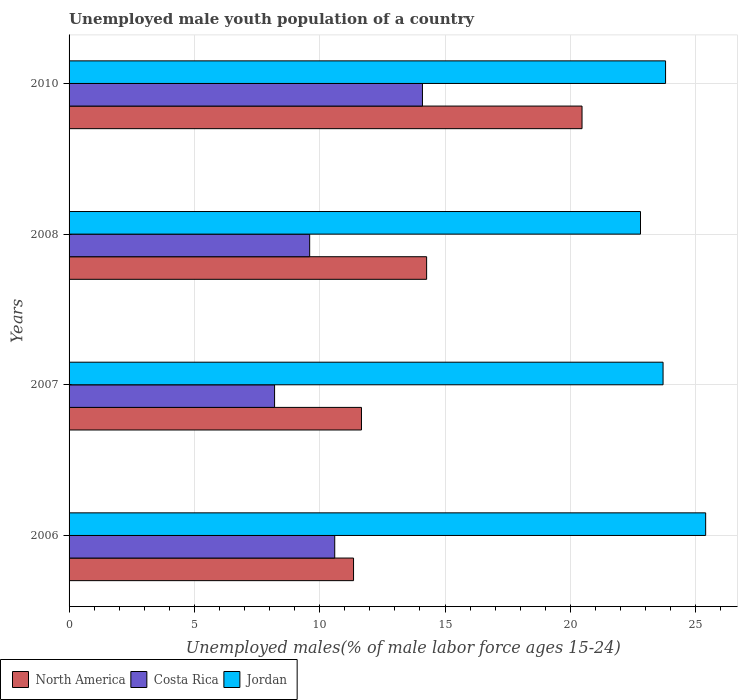How many different coloured bars are there?
Your answer should be very brief. 3. How many bars are there on the 3rd tick from the top?
Offer a very short reply. 3. What is the percentage of unemployed male youth population in North America in 2008?
Your answer should be compact. 14.27. Across all years, what is the maximum percentage of unemployed male youth population in North America?
Keep it short and to the point. 20.47. Across all years, what is the minimum percentage of unemployed male youth population in North America?
Provide a succinct answer. 11.35. In which year was the percentage of unemployed male youth population in Costa Rica maximum?
Provide a short and direct response. 2010. In which year was the percentage of unemployed male youth population in Jordan minimum?
Your answer should be very brief. 2008. What is the total percentage of unemployed male youth population in Jordan in the graph?
Ensure brevity in your answer.  95.7. What is the difference between the percentage of unemployed male youth population in Jordan in 2007 and that in 2008?
Make the answer very short. 0.9. What is the difference between the percentage of unemployed male youth population in Costa Rica in 2010 and the percentage of unemployed male youth population in Jordan in 2007?
Make the answer very short. -9.6. What is the average percentage of unemployed male youth population in Costa Rica per year?
Offer a terse response. 10.63. In the year 2007, what is the difference between the percentage of unemployed male youth population in Costa Rica and percentage of unemployed male youth population in North America?
Your answer should be very brief. -3.47. What is the ratio of the percentage of unemployed male youth population in Jordan in 2008 to that in 2010?
Keep it short and to the point. 0.96. Is the percentage of unemployed male youth population in Jordan in 2006 less than that in 2008?
Your answer should be very brief. No. Is the difference between the percentage of unemployed male youth population in Costa Rica in 2006 and 2010 greater than the difference between the percentage of unemployed male youth population in North America in 2006 and 2010?
Give a very brief answer. Yes. What is the difference between the highest and the second highest percentage of unemployed male youth population in Jordan?
Provide a short and direct response. 1.6. What is the difference between the highest and the lowest percentage of unemployed male youth population in Jordan?
Provide a short and direct response. 2.6. In how many years, is the percentage of unemployed male youth population in North America greater than the average percentage of unemployed male youth population in North America taken over all years?
Make the answer very short. 1. Is the sum of the percentage of unemployed male youth population in North America in 2007 and 2008 greater than the maximum percentage of unemployed male youth population in Costa Rica across all years?
Give a very brief answer. Yes. What does the 1st bar from the top in 2007 represents?
Your answer should be very brief. Jordan. What does the 3rd bar from the bottom in 2006 represents?
Keep it short and to the point. Jordan. Is it the case that in every year, the sum of the percentage of unemployed male youth population in Costa Rica and percentage of unemployed male youth population in North America is greater than the percentage of unemployed male youth population in Jordan?
Give a very brief answer. No. How many bars are there?
Your answer should be very brief. 12. Are all the bars in the graph horizontal?
Your response must be concise. Yes. Are the values on the major ticks of X-axis written in scientific E-notation?
Ensure brevity in your answer.  No. Does the graph contain any zero values?
Offer a very short reply. No. Where does the legend appear in the graph?
Provide a succinct answer. Bottom left. How many legend labels are there?
Provide a short and direct response. 3. What is the title of the graph?
Your answer should be very brief. Unemployed male youth population of a country. What is the label or title of the X-axis?
Make the answer very short. Unemployed males(% of male labor force ages 15-24). What is the Unemployed males(% of male labor force ages 15-24) in North America in 2006?
Give a very brief answer. 11.35. What is the Unemployed males(% of male labor force ages 15-24) of Costa Rica in 2006?
Make the answer very short. 10.6. What is the Unemployed males(% of male labor force ages 15-24) of Jordan in 2006?
Offer a very short reply. 25.4. What is the Unemployed males(% of male labor force ages 15-24) of North America in 2007?
Keep it short and to the point. 11.67. What is the Unemployed males(% of male labor force ages 15-24) of Costa Rica in 2007?
Your answer should be very brief. 8.2. What is the Unemployed males(% of male labor force ages 15-24) in Jordan in 2007?
Make the answer very short. 23.7. What is the Unemployed males(% of male labor force ages 15-24) of North America in 2008?
Your response must be concise. 14.27. What is the Unemployed males(% of male labor force ages 15-24) in Costa Rica in 2008?
Offer a terse response. 9.6. What is the Unemployed males(% of male labor force ages 15-24) of Jordan in 2008?
Ensure brevity in your answer.  22.8. What is the Unemployed males(% of male labor force ages 15-24) in North America in 2010?
Your answer should be compact. 20.47. What is the Unemployed males(% of male labor force ages 15-24) of Costa Rica in 2010?
Your answer should be very brief. 14.1. What is the Unemployed males(% of male labor force ages 15-24) of Jordan in 2010?
Keep it short and to the point. 23.8. Across all years, what is the maximum Unemployed males(% of male labor force ages 15-24) in North America?
Offer a very short reply. 20.47. Across all years, what is the maximum Unemployed males(% of male labor force ages 15-24) in Costa Rica?
Give a very brief answer. 14.1. Across all years, what is the maximum Unemployed males(% of male labor force ages 15-24) of Jordan?
Keep it short and to the point. 25.4. Across all years, what is the minimum Unemployed males(% of male labor force ages 15-24) of North America?
Offer a very short reply. 11.35. Across all years, what is the minimum Unemployed males(% of male labor force ages 15-24) of Costa Rica?
Keep it short and to the point. 8.2. Across all years, what is the minimum Unemployed males(% of male labor force ages 15-24) in Jordan?
Ensure brevity in your answer.  22.8. What is the total Unemployed males(% of male labor force ages 15-24) of North America in the graph?
Your answer should be very brief. 57.75. What is the total Unemployed males(% of male labor force ages 15-24) of Costa Rica in the graph?
Your answer should be compact. 42.5. What is the total Unemployed males(% of male labor force ages 15-24) in Jordan in the graph?
Offer a terse response. 95.7. What is the difference between the Unemployed males(% of male labor force ages 15-24) of North America in 2006 and that in 2007?
Give a very brief answer. -0.32. What is the difference between the Unemployed males(% of male labor force ages 15-24) in Costa Rica in 2006 and that in 2007?
Ensure brevity in your answer.  2.4. What is the difference between the Unemployed males(% of male labor force ages 15-24) of Jordan in 2006 and that in 2007?
Your answer should be very brief. 1.7. What is the difference between the Unemployed males(% of male labor force ages 15-24) in North America in 2006 and that in 2008?
Provide a short and direct response. -2.92. What is the difference between the Unemployed males(% of male labor force ages 15-24) of North America in 2006 and that in 2010?
Your response must be concise. -9.12. What is the difference between the Unemployed males(% of male labor force ages 15-24) of Costa Rica in 2006 and that in 2010?
Your response must be concise. -3.5. What is the difference between the Unemployed males(% of male labor force ages 15-24) of Jordan in 2006 and that in 2010?
Your answer should be compact. 1.6. What is the difference between the Unemployed males(% of male labor force ages 15-24) of North America in 2007 and that in 2008?
Keep it short and to the point. -2.6. What is the difference between the Unemployed males(% of male labor force ages 15-24) in Jordan in 2007 and that in 2008?
Provide a succinct answer. 0.9. What is the difference between the Unemployed males(% of male labor force ages 15-24) of North America in 2007 and that in 2010?
Offer a terse response. -8.8. What is the difference between the Unemployed males(% of male labor force ages 15-24) of North America in 2008 and that in 2010?
Make the answer very short. -6.2. What is the difference between the Unemployed males(% of male labor force ages 15-24) in North America in 2006 and the Unemployed males(% of male labor force ages 15-24) in Costa Rica in 2007?
Your answer should be compact. 3.15. What is the difference between the Unemployed males(% of male labor force ages 15-24) of North America in 2006 and the Unemployed males(% of male labor force ages 15-24) of Jordan in 2007?
Provide a short and direct response. -12.35. What is the difference between the Unemployed males(% of male labor force ages 15-24) in North America in 2006 and the Unemployed males(% of male labor force ages 15-24) in Costa Rica in 2008?
Provide a short and direct response. 1.75. What is the difference between the Unemployed males(% of male labor force ages 15-24) of North America in 2006 and the Unemployed males(% of male labor force ages 15-24) of Jordan in 2008?
Ensure brevity in your answer.  -11.45. What is the difference between the Unemployed males(% of male labor force ages 15-24) in North America in 2006 and the Unemployed males(% of male labor force ages 15-24) in Costa Rica in 2010?
Offer a very short reply. -2.75. What is the difference between the Unemployed males(% of male labor force ages 15-24) in North America in 2006 and the Unemployed males(% of male labor force ages 15-24) in Jordan in 2010?
Your answer should be very brief. -12.45. What is the difference between the Unemployed males(% of male labor force ages 15-24) of Costa Rica in 2006 and the Unemployed males(% of male labor force ages 15-24) of Jordan in 2010?
Make the answer very short. -13.2. What is the difference between the Unemployed males(% of male labor force ages 15-24) in North America in 2007 and the Unemployed males(% of male labor force ages 15-24) in Costa Rica in 2008?
Keep it short and to the point. 2.07. What is the difference between the Unemployed males(% of male labor force ages 15-24) in North America in 2007 and the Unemployed males(% of male labor force ages 15-24) in Jordan in 2008?
Your answer should be compact. -11.13. What is the difference between the Unemployed males(% of male labor force ages 15-24) of Costa Rica in 2007 and the Unemployed males(% of male labor force ages 15-24) of Jordan in 2008?
Your response must be concise. -14.6. What is the difference between the Unemployed males(% of male labor force ages 15-24) in North America in 2007 and the Unemployed males(% of male labor force ages 15-24) in Costa Rica in 2010?
Your response must be concise. -2.43. What is the difference between the Unemployed males(% of male labor force ages 15-24) of North America in 2007 and the Unemployed males(% of male labor force ages 15-24) of Jordan in 2010?
Provide a succinct answer. -12.13. What is the difference between the Unemployed males(% of male labor force ages 15-24) of Costa Rica in 2007 and the Unemployed males(% of male labor force ages 15-24) of Jordan in 2010?
Make the answer very short. -15.6. What is the difference between the Unemployed males(% of male labor force ages 15-24) of North America in 2008 and the Unemployed males(% of male labor force ages 15-24) of Jordan in 2010?
Give a very brief answer. -9.53. What is the average Unemployed males(% of male labor force ages 15-24) in North America per year?
Provide a short and direct response. 14.44. What is the average Unemployed males(% of male labor force ages 15-24) in Costa Rica per year?
Provide a succinct answer. 10.62. What is the average Unemployed males(% of male labor force ages 15-24) in Jordan per year?
Give a very brief answer. 23.93. In the year 2006, what is the difference between the Unemployed males(% of male labor force ages 15-24) of North America and Unemployed males(% of male labor force ages 15-24) of Costa Rica?
Give a very brief answer. 0.75. In the year 2006, what is the difference between the Unemployed males(% of male labor force ages 15-24) in North America and Unemployed males(% of male labor force ages 15-24) in Jordan?
Provide a short and direct response. -14.05. In the year 2006, what is the difference between the Unemployed males(% of male labor force ages 15-24) in Costa Rica and Unemployed males(% of male labor force ages 15-24) in Jordan?
Provide a succinct answer. -14.8. In the year 2007, what is the difference between the Unemployed males(% of male labor force ages 15-24) in North America and Unemployed males(% of male labor force ages 15-24) in Costa Rica?
Ensure brevity in your answer.  3.47. In the year 2007, what is the difference between the Unemployed males(% of male labor force ages 15-24) of North America and Unemployed males(% of male labor force ages 15-24) of Jordan?
Your answer should be very brief. -12.03. In the year 2007, what is the difference between the Unemployed males(% of male labor force ages 15-24) in Costa Rica and Unemployed males(% of male labor force ages 15-24) in Jordan?
Give a very brief answer. -15.5. In the year 2008, what is the difference between the Unemployed males(% of male labor force ages 15-24) of North America and Unemployed males(% of male labor force ages 15-24) of Costa Rica?
Offer a very short reply. 4.67. In the year 2008, what is the difference between the Unemployed males(% of male labor force ages 15-24) of North America and Unemployed males(% of male labor force ages 15-24) of Jordan?
Offer a terse response. -8.53. In the year 2010, what is the difference between the Unemployed males(% of male labor force ages 15-24) of North America and Unemployed males(% of male labor force ages 15-24) of Costa Rica?
Give a very brief answer. 6.37. In the year 2010, what is the difference between the Unemployed males(% of male labor force ages 15-24) of North America and Unemployed males(% of male labor force ages 15-24) of Jordan?
Provide a short and direct response. -3.33. What is the ratio of the Unemployed males(% of male labor force ages 15-24) in North America in 2006 to that in 2007?
Offer a terse response. 0.97. What is the ratio of the Unemployed males(% of male labor force ages 15-24) of Costa Rica in 2006 to that in 2007?
Keep it short and to the point. 1.29. What is the ratio of the Unemployed males(% of male labor force ages 15-24) of Jordan in 2006 to that in 2007?
Ensure brevity in your answer.  1.07. What is the ratio of the Unemployed males(% of male labor force ages 15-24) in North America in 2006 to that in 2008?
Provide a succinct answer. 0.8. What is the ratio of the Unemployed males(% of male labor force ages 15-24) in Costa Rica in 2006 to that in 2008?
Your answer should be compact. 1.1. What is the ratio of the Unemployed males(% of male labor force ages 15-24) in Jordan in 2006 to that in 2008?
Give a very brief answer. 1.11. What is the ratio of the Unemployed males(% of male labor force ages 15-24) in North America in 2006 to that in 2010?
Offer a terse response. 0.55. What is the ratio of the Unemployed males(% of male labor force ages 15-24) in Costa Rica in 2006 to that in 2010?
Give a very brief answer. 0.75. What is the ratio of the Unemployed males(% of male labor force ages 15-24) in Jordan in 2006 to that in 2010?
Keep it short and to the point. 1.07. What is the ratio of the Unemployed males(% of male labor force ages 15-24) of North America in 2007 to that in 2008?
Your response must be concise. 0.82. What is the ratio of the Unemployed males(% of male labor force ages 15-24) of Costa Rica in 2007 to that in 2008?
Provide a short and direct response. 0.85. What is the ratio of the Unemployed males(% of male labor force ages 15-24) of Jordan in 2007 to that in 2008?
Offer a terse response. 1.04. What is the ratio of the Unemployed males(% of male labor force ages 15-24) in North America in 2007 to that in 2010?
Your response must be concise. 0.57. What is the ratio of the Unemployed males(% of male labor force ages 15-24) in Costa Rica in 2007 to that in 2010?
Offer a terse response. 0.58. What is the ratio of the Unemployed males(% of male labor force ages 15-24) in Jordan in 2007 to that in 2010?
Your answer should be very brief. 1. What is the ratio of the Unemployed males(% of male labor force ages 15-24) of North America in 2008 to that in 2010?
Make the answer very short. 0.7. What is the ratio of the Unemployed males(% of male labor force ages 15-24) in Costa Rica in 2008 to that in 2010?
Ensure brevity in your answer.  0.68. What is the ratio of the Unemployed males(% of male labor force ages 15-24) in Jordan in 2008 to that in 2010?
Keep it short and to the point. 0.96. What is the difference between the highest and the second highest Unemployed males(% of male labor force ages 15-24) in North America?
Offer a terse response. 6.2. What is the difference between the highest and the second highest Unemployed males(% of male labor force ages 15-24) of Costa Rica?
Provide a short and direct response. 3.5. What is the difference between the highest and the lowest Unemployed males(% of male labor force ages 15-24) of North America?
Your answer should be very brief. 9.12. 